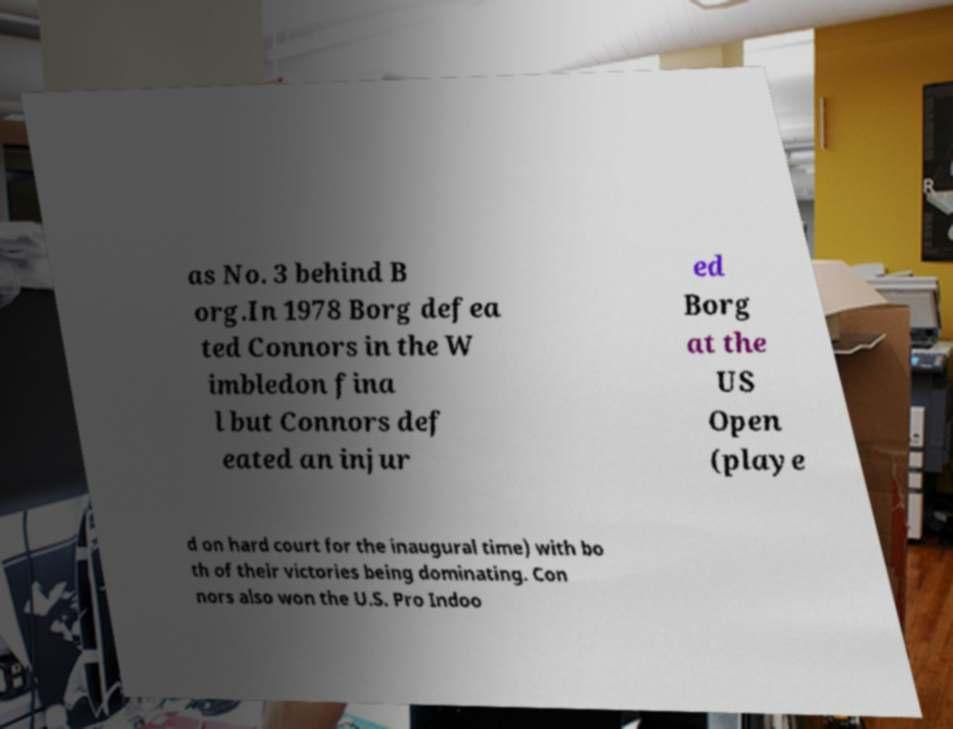There's text embedded in this image that I need extracted. Can you transcribe it verbatim? as No. 3 behind B org.In 1978 Borg defea ted Connors in the W imbledon fina l but Connors def eated an injur ed Borg at the US Open (playe d on hard court for the inaugural time) with bo th of their victories being dominating. Con nors also won the U.S. Pro Indoo 